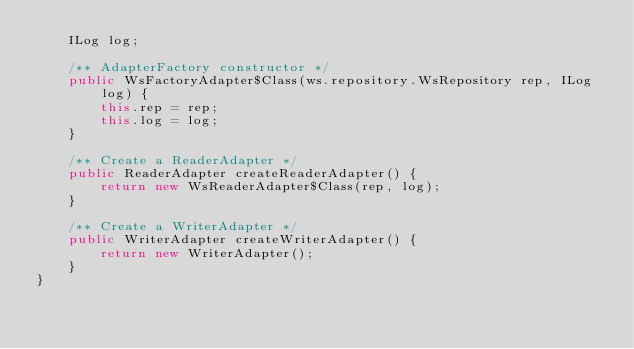<code> <loc_0><loc_0><loc_500><loc_500><_Java_>	ILog log;

	/** AdapterFactory constructor */
	public WsFactoryAdapter$Class(ws.repository.WsRepository rep, ILog log) {
		this.rep = rep;
		this.log = log;
	}

	/** Create a ReaderAdapter */
	public ReaderAdapter createReaderAdapter() {
		return new WsReaderAdapter$Class(rep, log);
	}

	/** Create a WriterAdapter */
	public WriterAdapter createWriterAdapter() {
		return new WriterAdapter();
	}
}
</code> 